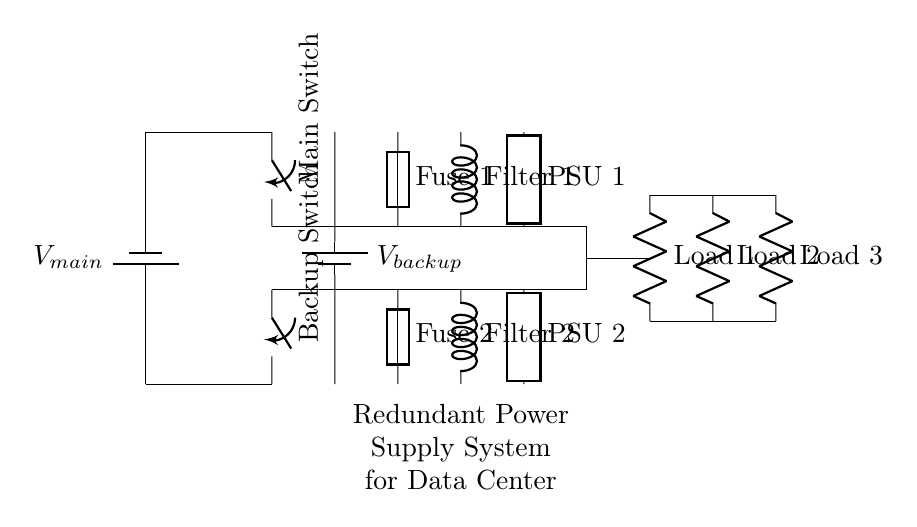What are the main voltage sources in the circuit? The two main voltage sources visible in the circuit are labeled as V_main and V_backup. These represent the main power supply and the backup power supply, respectively.
Answer: V_main, V_backup How many loads are present in this circuit? The circuit diagram shows three loads indicated as Load 1, Load 2, and Load 3. Each load is connected in parallel to the rest of the circuit, confirming there are three loads.
Answer: 3 What type of circuit is this? This circuit is a parallel circuit design, as evidenced by the multiple branches connected along the same voltage nodes, allowing current to flow through each branch independently.
Answer: Parallel What is the purpose of the switches in this design? The main switch and backup switch allow for the selection between the main power source and backup power source, ensuring redundancy in the power supply system. When one source fails, the switch can redirect power from the other source, maintaining operation.
Answer: Redundancy What device protects the circuit from overload? The fuses labeled Fuse 1 and Fuse 2 serve to protect the circuit from overload conditions. They will break the circuit if the current exceeds a specified limit, preventing damage to the components.
Answer: Fuses What is the role of the filters in this design? The filters labeled Filter 1 and Filter 2 are intended to smooth out voltage fluctuations and reduce noise in the power supply system, ensuring stable operation of connected loads.
Answer: Noise reduction Which component connects the power sources to the loads? The generic components labeled PSU 1 and PSU 2 represent power supply units that deliver power from the main and backup sources to the loads, providing the necessary energy for operation.
Answer: Power supply units 